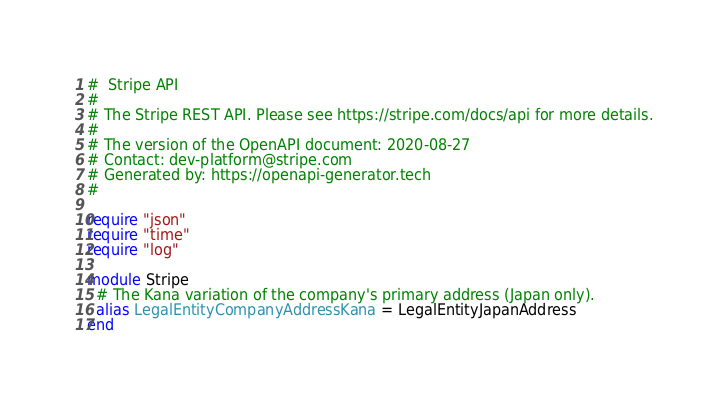Convert code to text. <code><loc_0><loc_0><loc_500><loc_500><_Crystal_>#  Stripe API
#
# The Stripe REST API. Please see https://stripe.com/docs/api for more details.
#
# The version of the OpenAPI document: 2020-08-27
# Contact: dev-platform@stripe.com
# Generated by: https://openapi-generator.tech
#

require "json"
require "time"
require "log"

module Stripe
  # The Kana variation of the company's primary address (Japan only).
  alias LegalEntityCompanyAddressKana = LegalEntityJapanAddress
end
</code> 